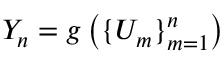Convert formula to latex. <formula><loc_0><loc_0><loc_500><loc_500>Y _ { n } = g \left ( \{ U _ { m } \} _ { m = 1 } ^ { n } \right )</formula> 